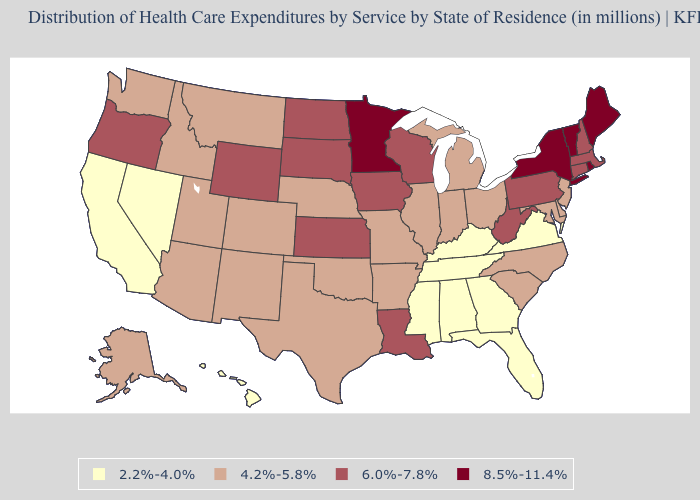Does Connecticut have the highest value in the Northeast?
Keep it brief. No. What is the value of Maine?
Quick response, please. 8.5%-11.4%. Name the states that have a value in the range 4.2%-5.8%?
Quick response, please. Alaska, Arizona, Arkansas, Colorado, Delaware, Idaho, Illinois, Indiana, Maryland, Michigan, Missouri, Montana, Nebraska, New Jersey, New Mexico, North Carolina, Ohio, Oklahoma, South Carolina, Texas, Utah, Washington. What is the value of Florida?
Answer briefly. 2.2%-4.0%. Which states have the highest value in the USA?
Short answer required. Maine, Minnesota, New York, Rhode Island, Vermont. What is the value of Ohio?
Write a very short answer. 4.2%-5.8%. Name the states that have a value in the range 2.2%-4.0%?
Write a very short answer. Alabama, California, Florida, Georgia, Hawaii, Kentucky, Mississippi, Nevada, Tennessee, Virginia. Does Missouri have a lower value than Vermont?
Write a very short answer. Yes. Does Kansas have the lowest value in the MidWest?
Be succinct. No. Does Massachusetts have a lower value than South Carolina?
Give a very brief answer. No. Name the states that have a value in the range 6.0%-7.8%?
Write a very short answer. Connecticut, Iowa, Kansas, Louisiana, Massachusetts, New Hampshire, North Dakota, Oregon, Pennsylvania, South Dakota, West Virginia, Wisconsin, Wyoming. Which states have the lowest value in the Northeast?
Give a very brief answer. New Jersey. Name the states that have a value in the range 8.5%-11.4%?
Short answer required. Maine, Minnesota, New York, Rhode Island, Vermont. What is the value of Minnesota?
Short answer required. 8.5%-11.4%. What is the lowest value in the West?
Be succinct. 2.2%-4.0%. 